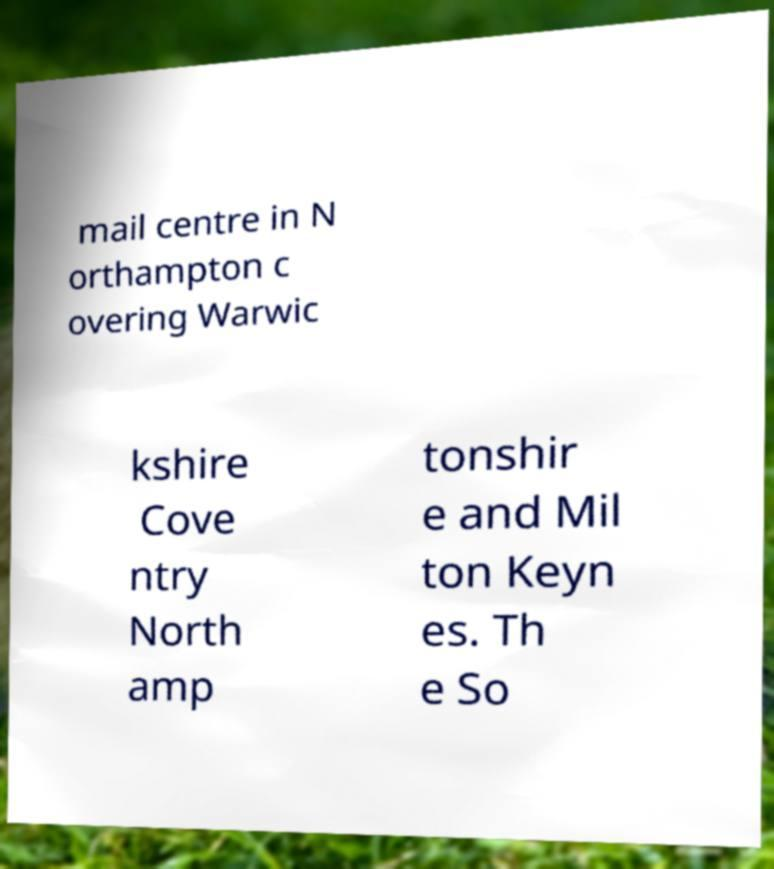For documentation purposes, I need the text within this image transcribed. Could you provide that? mail centre in N orthampton c overing Warwic kshire Cove ntry North amp tonshir e and Mil ton Keyn es. Th e So 